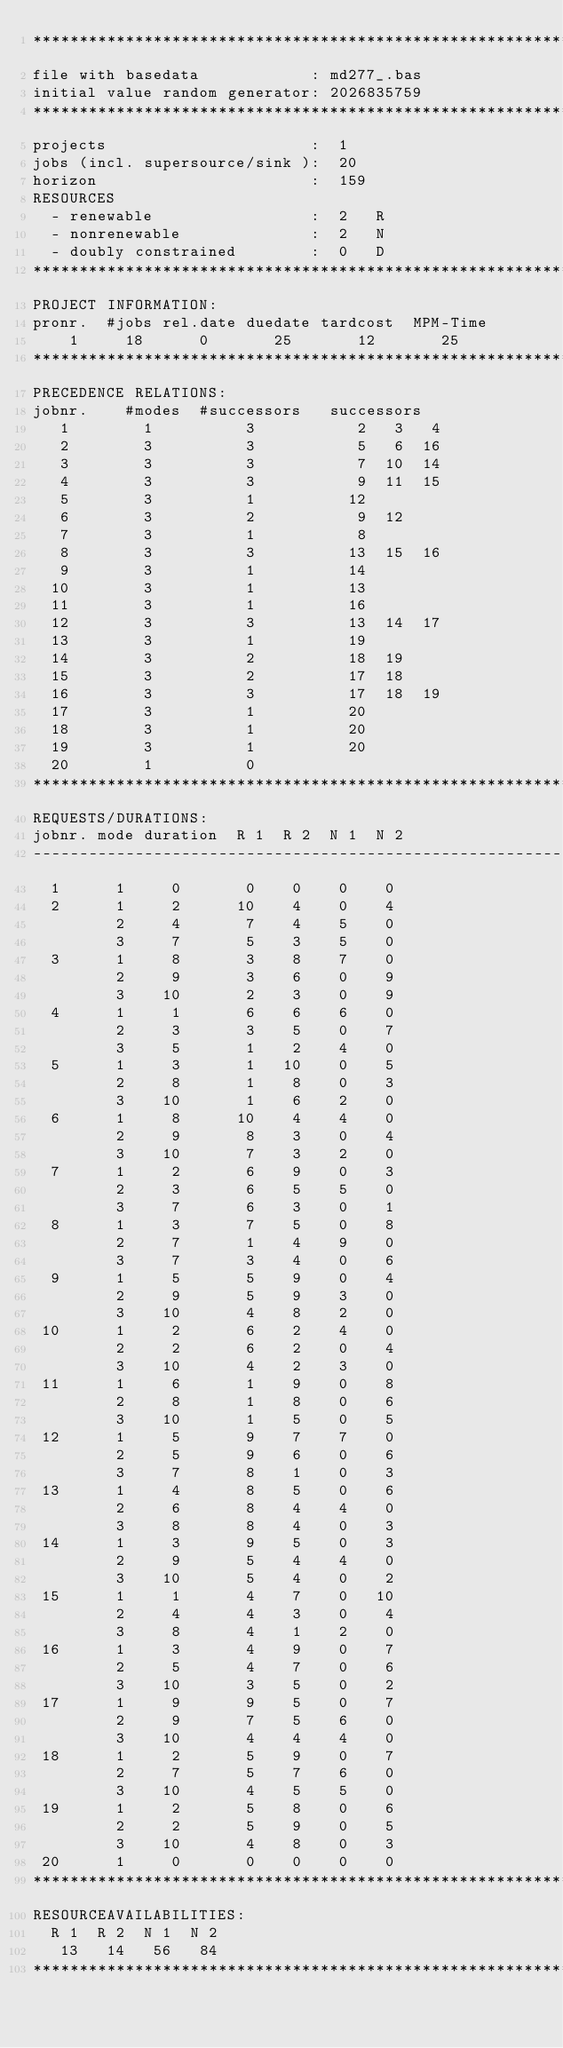<code> <loc_0><loc_0><loc_500><loc_500><_ObjectiveC_>************************************************************************
file with basedata            : md277_.bas
initial value random generator: 2026835759
************************************************************************
projects                      :  1
jobs (incl. supersource/sink ):  20
horizon                       :  159
RESOURCES
  - renewable                 :  2   R
  - nonrenewable              :  2   N
  - doubly constrained        :  0   D
************************************************************************
PROJECT INFORMATION:
pronr.  #jobs rel.date duedate tardcost  MPM-Time
    1     18      0       25       12       25
************************************************************************
PRECEDENCE RELATIONS:
jobnr.    #modes  #successors   successors
   1        1          3           2   3   4
   2        3          3           5   6  16
   3        3          3           7  10  14
   4        3          3           9  11  15
   5        3          1          12
   6        3          2           9  12
   7        3          1           8
   8        3          3          13  15  16
   9        3          1          14
  10        3          1          13
  11        3          1          16
  12        3          3          13  14  17
  13        3          1          19
  14        3          2          18  19
  15        3          2          17  18
  16        3          3          17  18  19
  17        3          1          20
  18        3          1          20
  19        3          1          20
  20        1          0        
************************************************************************
REQUESTS/DURATIONS:
jobnr. mode duration  R 1  R 2  N 1  N 2
------------------------------------------------------------------------
  1      1     0       0    0    0    0
  2      1     2      10    4    0    4
         2     4       7    4    5    0
         3     7       5    3    5    0
  3      1     8       3    8    7    0
         2     9       3    6    0    9
         3    10       2    3    0    9
  4      1     1       6    6    6    0
         2     3       3    5    0    7
         3     5       1    2    4    0
  5      1     3       1   10    0    5
         2     8       1    8    0    3
         3    10       1    6    2    0
  6      1     8      10    4    4    0
         2     9       8    3    0    4
         3    10       7    3    2    0
  7      1     2       6    9    0    3
         2     3       6    5    5    0
         3     7       6    3    0    1
  8      1     3       7    5    0    8
         2     7       1    4    9    0
         3     7       3    4    0    6
  9      1     5       5    9    0    4
         2     9       5    9    3    0
         3    10       4    8    2    0
 10      1     2       6    2    4    0
         2     2       6    2    0    4
         3    10       4    2    3    0
 11      1     6       1    9    0    8
         2     8       1    8    0    6
         3    10       1    5    0    5
 12      1     5       9    7    7    0
         2     5       9    6    0    6
         3     7       8    1    0    3
 13      1     4       8    5    0    6
         2     6       8    4    4    0
         3     8       8    4    0    3
 14      1     3       9    5    0    3
         2     9       5    4    4    0
         3    10       5    4    0    2
 15      1     1       4    7    0   10
         2     4       4    3    0    4
         3     8       4    1    2    0
 16      1     3       4    9    0    7
         2     5       4    7    0    6
         3    10       3    5    0    2
 17      1     9       9    5    0    7
         2     9       7    5    6    0
         3    10       4    4    4    0
 18      1     2       5    9    0    7
         2     7       5    7    6    0
         3    10       4    5    5    0
 19      1     2       5    8    0    6
         2     2       5    9    0    5
         3    10       4    8    0    3
 20      1     0       0    0    0    0
************************************************************************
RESOURCEAVAILABILITIES:
  R 1  R 2  N 1  N 2
   13   14   56   84
************************************************************************
</code> 